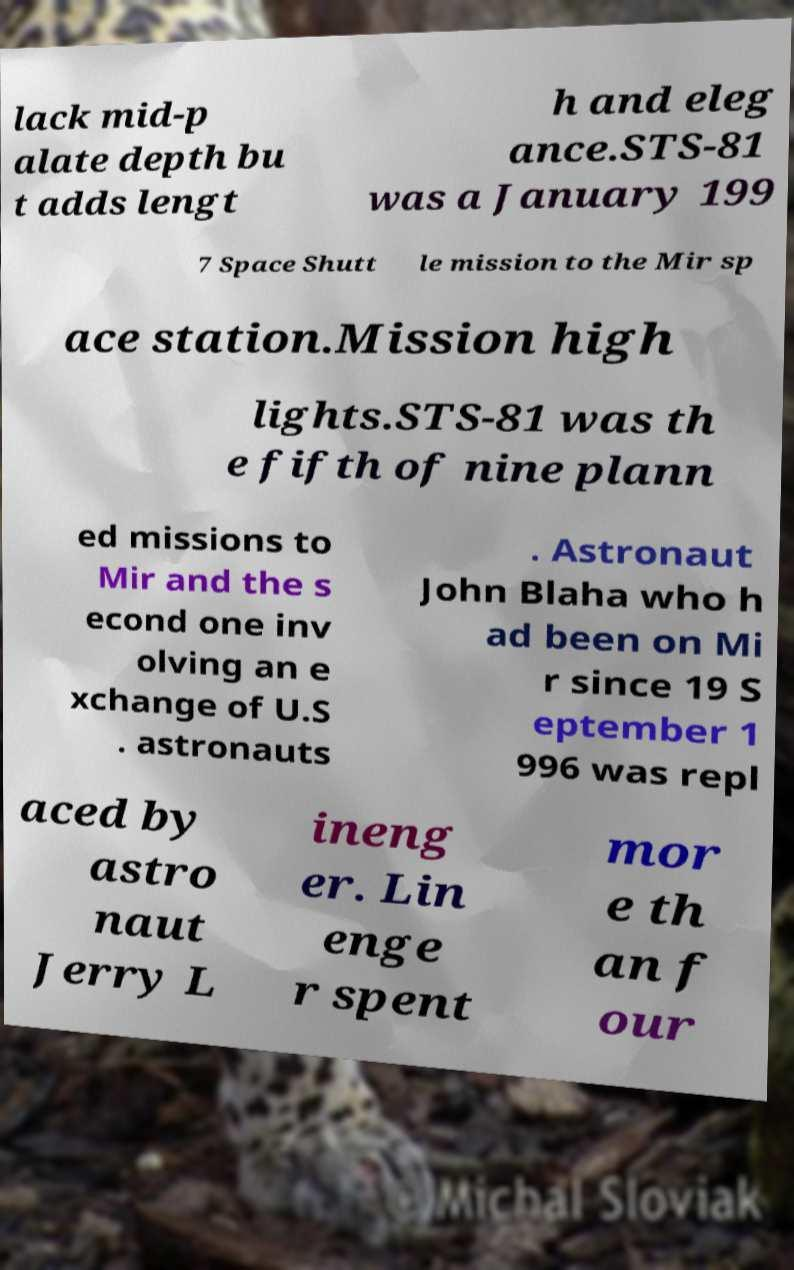Could you extract and type out the text from this image? lack mid-p alate depth bu t adds lengt h and eleg ance.STS-81 was a January 199 7 Space Shutt le mission to the Mir sp ace station.Mission high lights.STS-81 was th e fifth of nine plann ed missions to Mir and the s econd one inv olving an e xchange of U.S . astronauts . Astronaut John Blaha who h ad been on Mi r since 19 S eptember 1 996 was repl aced by astro naut Jerry L ineng er. Lin enge r spent mor e th an f our 